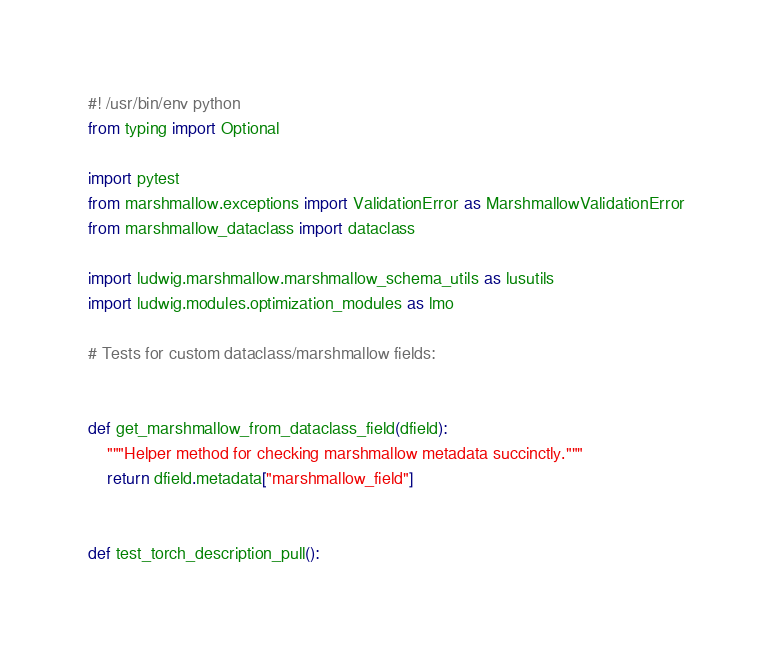Convert code to text. <code><loc_0><loc_0><loc_500><loc_500><_Python_>#! /usr/bin/env python
from typing import Optional

import pytest
from marshmallow.exceptions import ValidationError as MarshmallowValidationError
from marshmallow_dataclass import dataclass

import ludwig.marshmallow.marshmallow_schema_utils as lusutils
import ludwig.modules.optimization_modules as lmo

# Tests for custom dataclass/marshmallow fields:


def get_marshmallow_from_dataclass_field(dfield):
    """Helper method for checking marshmallow metadata succinctly."""
    return dfield.metadata["marshmallow_field"]


def test_torch_description_pull():</code> 